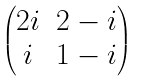<formula> <loc_0><loc_0><loc_500><loc_500>\begin{pmatrix} 2 i & 2 - i \\ i & 1 - i \end{pmatrix}</formula> 